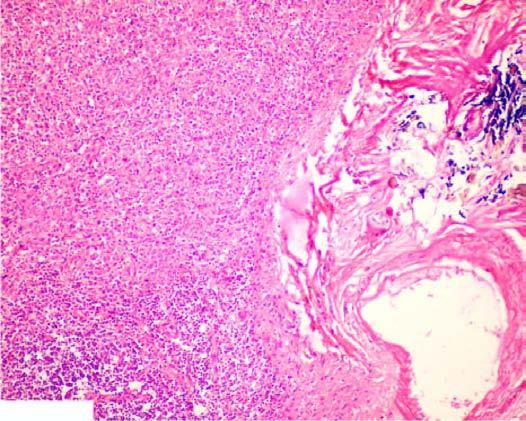what are dilated and congested?
Answer the question using a single word or phrase. The sinuses 